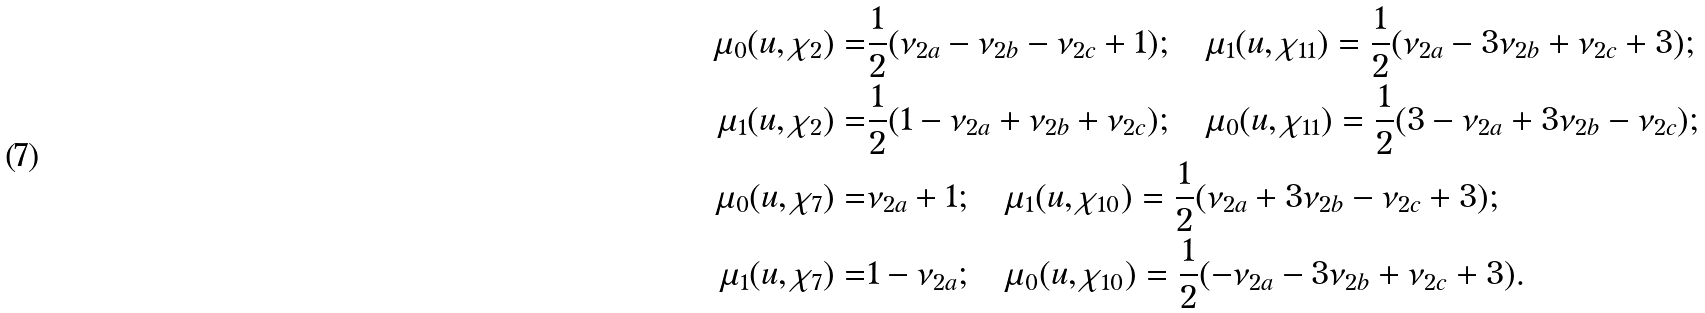Convert formula to latex. <formula><loc_0><loc_0><loc_500><loc_500>\mu _ { 0 } ( u , \chi _ { 2 } ) = & \frac { 1 } { 2 } ( \nu _ { 2 a } - \nu _ { 2 b } - \nu _ { 2 c } + 1 ) ; \quad \mu _ { 1 } ( u , \chi _ { 1 1 } ) = \frac { 1 } { 2 } ( \nu _ { 2 a } - 3 \nu _ { 2 b } + \nu _ { 2 c } + 3 ) ; \\ \mu _ { 1 } ( u , \chi _ { 2 } ) = & \frac { 1 } { 2 } ( 1 - \nu _ { 2 a } + \nu _ { 2 b } + \nu _ { 2 c } ) ; \quad \mu _ { 0 } ( u , \chi _ { 1 1 } ) = \frac { 1 } { 2 } ( 3 - \nu _ { 2 a } + 3 \nu _ { 2 b } - \nu _ { 2 c } ) ; \\ \mu _ { 0 } ( u , \chi _ { 7 } ) = & \nu _ { 2 a } + 1 ; \quad \mu _ { 1 } ( u , \chi _ { 1 0 } ) = \frac { 1 } { 2 } ( \nu _ { 2 a } + 3 \nu _ { 2 b } - \nu _ { 2 c } + 3 ) ; \\ \mu _ { 1 } ( u , \chi _ { 7 } ) = & 1 - \nu _ { 2 a } ; \quad \mu _ { 0 } ( u , \chi _ { 1 0 } ) = \frac { 1 } { 2 } ( - \nu _ { 2 a } - 3 \nu _ { 2 b } + \nu _ { 2 c } + 3 ) . \\</formula> 